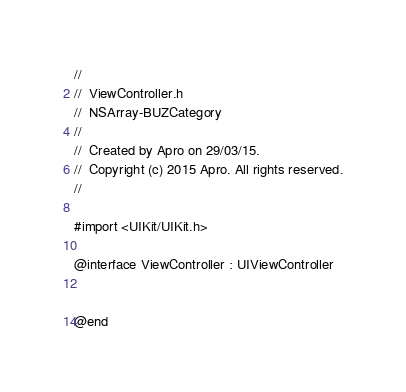Convert code to text. <code><loc_0><loc_0><loc_500><loc_500><_C_>//
//  ViewController.h
//  NSArray-BUZCategory
//
//  Created by Apro on 29/03/15.
//  Copyright (c) 2015 Apro. All rights reserved.
//

#import <UIKit/UIKit.h>

@interface ViewController : UIViewController


@end

</code> 